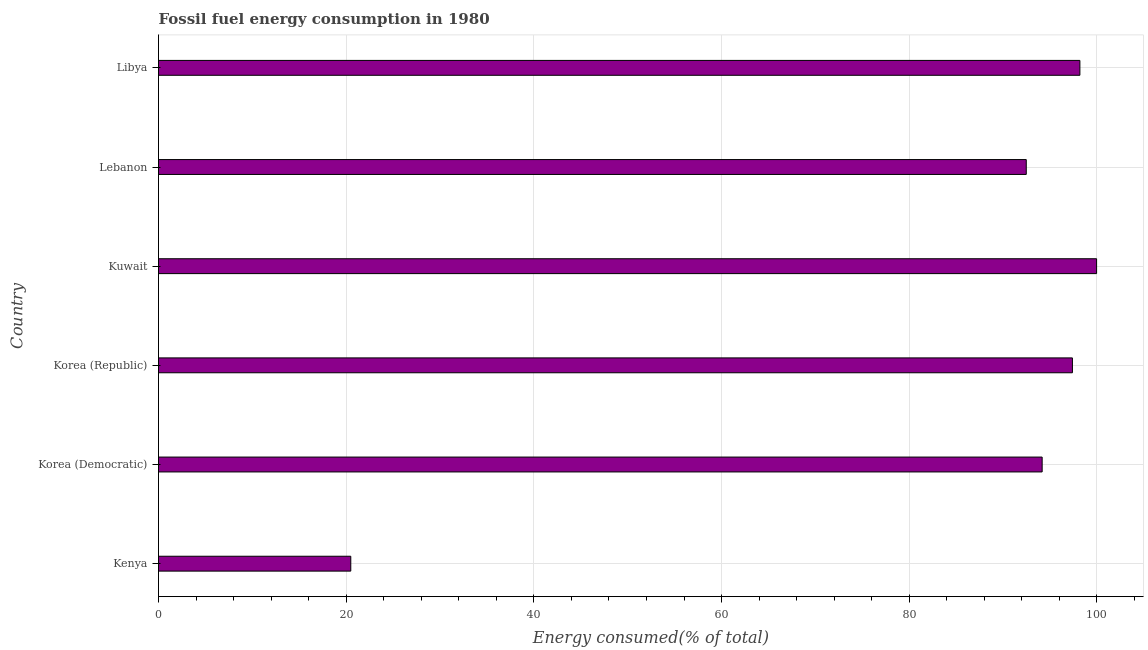What is the title of the graph?
Keep it short and to the point. Fossil fuel energy consumption in 1980. What is the label or title of the X-axis?
Keep it short and to the point. Energy consumed(% of total). What is the label or title of the Y-axis?
Make the answer very short. Country. What is the fossil fuel energy consumption in Libya?
Provide a short and direct response. 98.19. Across all countries, what is the maximum fossil fuel energy consumption?
Your answer should be compact. 99.96. Across all countries, what is the minimum fossil fuel energy consumption?
Offer a very short reply. 20.49. In which country was the fossil fuel energy consumption maximum?
Offer a very short reply. Kuwait. In which country was the fossil fuel energy consumption minimum?
Your answer should be very brief. Kenya. What is the sum of the fossil fuel energy consumption?
Ensure brevity in your answer.  502.66. What is the difference between the fossil fuel energy consumption in Korea (Democratic) and Lebanon?
Make the answer very short. 1.69. What is the average fossil fuel energy consumption per country?
Provide a succinct answer. 83.78. What is the median fossil fuel energy consumption?
Your answer should be compact. 95.78. In how many countries, is the fossil fuel energy consumption greater than 12 %?
Give a very brief answer. 6. What is the ratio of the fossil fuel energy consumption in Korea (Democratic) to that in Lebanon?
Offer a very short reply. 1.02. Is the fossil fuel energy consumption in Korea (Democratic) less than that in Libya?
Your answer should be compact. Yes. Is the difference between the fossil fuel energy consumption in Korea (Democratic) and Lebanon greater than the difference between any two countries?
Keep it short and to the point. No. What is the difference between the highest and the second highest fossil fuel energy consumption?
Provide a short and direct response. 1.78. What is the difference between the highest and the lowest fossil fuel energy consumption?
Make the answer very short. 79.48. In how many countries, is the fossil fuel energy consumption greater than the average fossil fuel energy consumption taken over all countries?
Offer a terse response. 5. How many bars are there?
Give a very brief answer. 6. How many countries are there in the graph?
Offer a very short reply. 6. What is the difference between two consecutive major ticks on the X-axis?
Ensure brevity in your answer.  20. Are the values on the major ticks of X-axis written in scientific E-notation?
Offer a very short reply. No. What is the Energy consumed(% of total) in Kenya?
Your answer should be very brief. 20.49. What is the Energy consumed(% of total) of Korea (Democratic)?
Provide a succinct answer. 94.16. What is the Energy consumed(% of total) in Korea (Republic)?
Keep it short and to the point. 97.39. What is the Energy consumed(% of total) of Kuwait?
Provide a succinct answer. 99.96. What is the Energy consumed(% of total) of Lebanon?
Provide a succinct answer. 92.47. What is the Energy consumed(% of total) in Libya?
Offer a very short reply. 98.19. What is the difference between the Energy consumed(% of total) in Kenya and Korea (Democratic)?
Keep it short and to the point. -73.67. What is the difference between the Energy consumed(% of total) in Kenya and Korea (Republic)?
Offer a very short reply. -76.9. What is the difference between the Energy consumed(% of total) in Kenya and Kuwait?
Offer a very short reply. -79.48. What is the difference between the Energy consumed(% of total) in Kenya and Lebanon?
Ensure brevity in your answer.  -71.98. What is the difference between the Energy consumed(% of total) in Kenya and Libya?
Give a very brief answer. -77.7. What is the difference between the Energy consumed(% of total) in Korea (Democratic) and Korea (Republic)?
Offer a terse response. -3.23. What is the difference between the Energy consumed(% of total) in Korea (Democratic) and Kuwait?
Your response must be concise. -5.8. What is the difference between the Energy consumed(% of total) in Korea (Democratic) and Lebanon?
Your answer should be very brief. 1.69. What is the difference between the Energy consumed(% of total) in Korea (Democratic) and Libya?
Make the answer very short. -4.02. What is the difference between the Energy consumed(% of total) in Korea (Republic) and Kuwait?
Your answer should be compact. -2.57. What is the difference between the Energy consumed(% of total) in Korea (Republic) and Lebanon?
Give a very brief answer. 4.92. What is the difference between the Energy consumed(% of total) in Korea (Republic) and Libya?
Provide a short and direct response. -0.8. What is the difference between the Energy consumed(% of total) in Kuwait and Lebanon?
Keep it short and to the point. 7.49. What is the difference between the Energy consumed(% of total) in Kuwait and Libya?
Give a very brief answer. 1.78. What is the difference between the Energy consumed(% of total) in Lebanon and Libya?
Provide a short and direct response. -5.71. What is the ratio of the Energy consumed(% of total) in Kenya to that in Korea (Democratic)?
Your response must be concise. 0.22. What is the ratio of the Energy consumed(% of total) in Kenya to that in Korea (Republic)?
Provide a succinct answer. 0.21. What is the ratio of the Energy consumed(% of total) in Kenya to that in Kuwait?
Ensure brevity in your answer.  0.2. What is the ratio of the Energy consumed(% of total) in Kenya to that in Lebanon?
Give a very brief answer. 0.22. What is the ratio of the Energy consumed(% of total) in Kenya to that in Libya?
Make the answer very short. 0.21. What is the ratio of the Energy consumed(% of total) in Korea (Democratic) to that in Kuwait?
Offer a very short reply. 0.94. What is the ratio of the Energy consumed(% of total) in Korea (Republic) to that in Lebanon?
Provide a short and direct response. 1.05. What is the ratio of the Energy consumed(% of total) in Kuwait to that in Lebanon?
Provide a short and direct response. 1.08. What is the ratio of the Energy consumed(% of total) in Lebanon to that in Libya?
Ensure brevity in your answer.  0.94. 